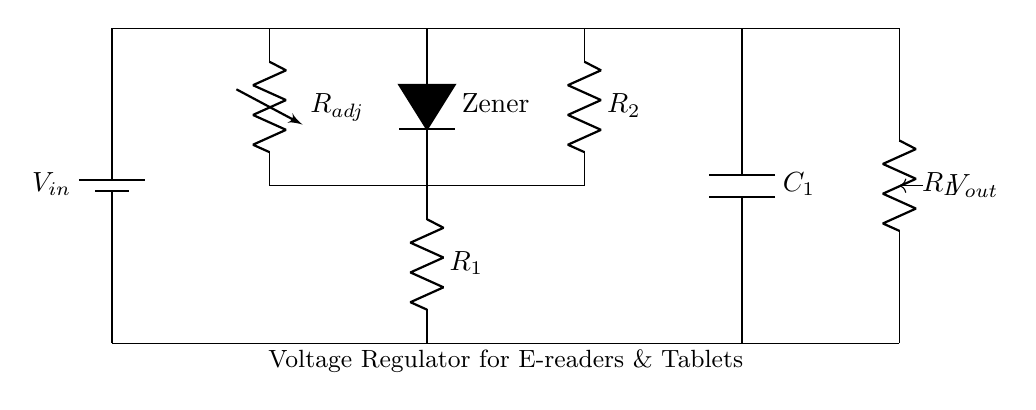What component is used to stabilize voltage in this circuit? The Zener diode is used to stabilize voltage by allowing current to flow in the reverse direction when the voltage exceeds a certain level, thus maintaining a constant output voltage.
Answer: Zener diode What is the purpose of the variable resistor in this circuit? The variable resistor adjusts the output voltage by changing the resistance; this allows for fine-tuning the voltage supplied to the e-reader or tablet.
Answer: Adjust output voltage What is the output voltage of the circuit? The exact output voltage is not specified in the diagram, but it is regulated to a level determined by the Zener diode and the resistors involved.
Answer: Regulated voltage How many resistors are present in this circuit? There are three resistors in total, including one variable resistor and two fixed resistors.
Answer: Three resistors Which component stores energy in this circuit? The capacitor stores energy in the form of an electric field when it is charged, supplying power when the circuit demands it.
Answer: Capacitor What is the significance of the battery in this circuit? The battery provides the necessary input voltage that powers the entire circuit, which is then regulated for use by the e-readers and tablets.
Answer: Input voltage source What does the load resistor represent in this circuit? The load resistor simulates the power consumption of the e-reader or tablet, allowing the voltage regulator to maintain the desired output under actual working conditions.
Answer: Power consumption 